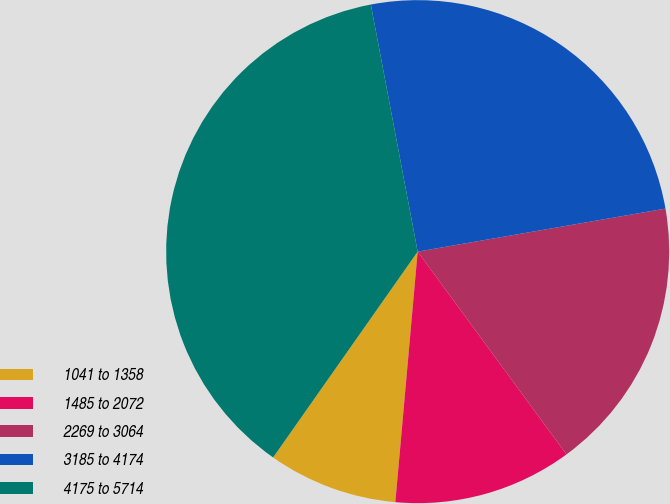Convert chart to OTSL. <chart><loc_0><loc_0><loc_500><loc_500><pie_chart><fcel>1041 to 1358<fcel>1485 to 2072<fcel>2269 to 3064<fcel>3185 to 4174<fcel>4175 to 5714<nl><fcel>8.33%<fcel>11.49%<fcel>17.66%<fcel>25.24%<fcel>37.27%<nl></chart> 